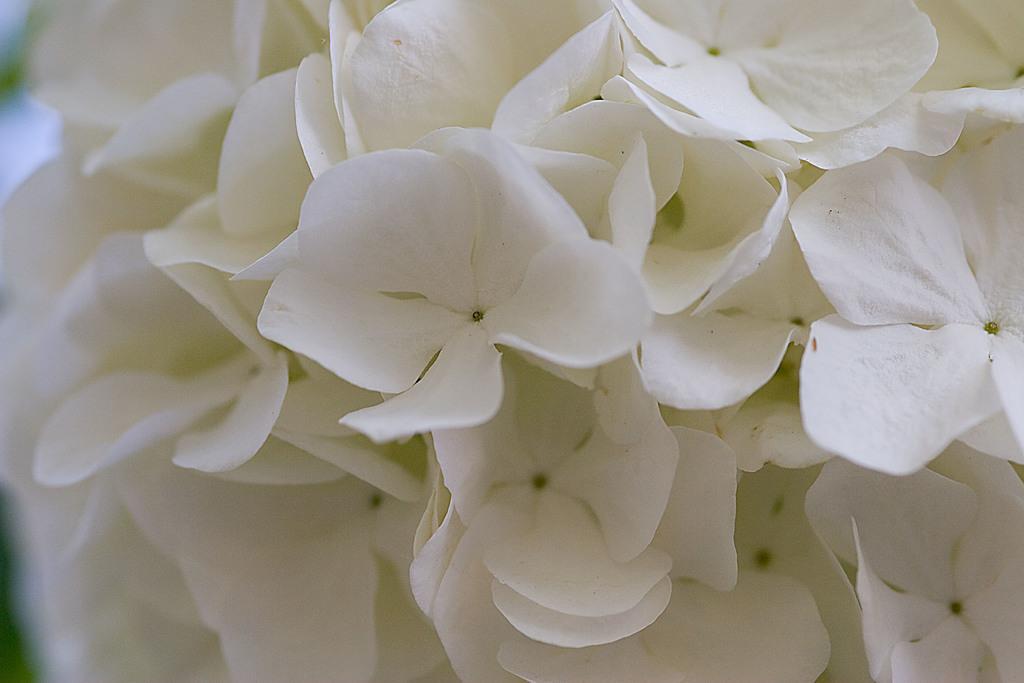How would you summarize this image in a sentence or two? In this image, we can see some white colored flowers. 